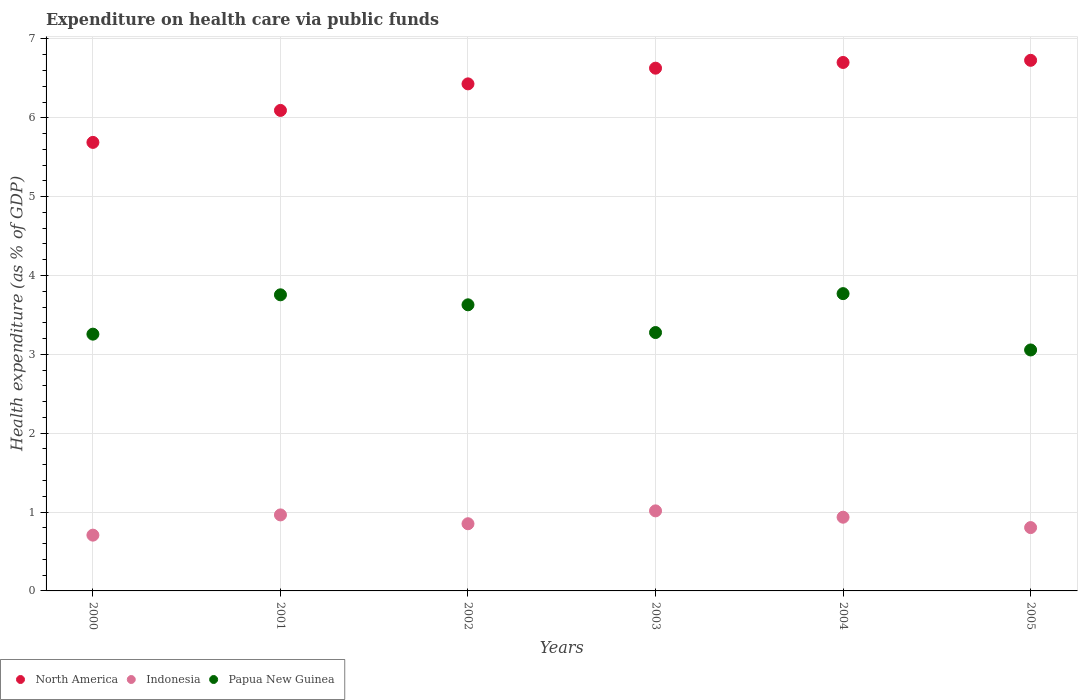How many different coloured dotlines are there?
Your response must be concise. 3. What is the expenditure made on health care in North America in 2005?
Give a very brief answer. 6.73. Across all years, what is the maximum expenditure made on health care in Indonesia?
Make the answer very short. 1.02. Across all years, what is the minimum expenditure made on health care in Indonesia?
Your answer should be very brief. 0.71. In which year was the expenditure made on health care in Indonesia maximum?
Offer a terse response. 2003. In which year was the expenditure made on health care in Indonesia minimum?
Ensure brevity in your answer.  2000. What is the total expenditure made on health care in Papua New Guinea in the graph?
Provide a short and direct response. 20.74. What is the difference between the expenditure made on health care in Indonesia in 2004 and that in 2005?
Provide a succinct answer. 0.13. What is the difference between the expenditure made on health care in North America in 2003 and the expenditure made on health care in Papua New Guinea in 2005?
Your response must be concise. 3.57. What is the average expenditure made on health care in North America per year?
Your response must be concise. 6.38. In the year 2003, what is the difference between the expenditure made on health care in Papua New Guinea and expenditure made on health care in Indonesia?
Provide a succinct answer. 2.26. In how many years, is the expenditure made on health care in Indonesia greater than 2.2 %?
Ensure brevity in your answer.  0. What is the ratio of the expenditure made on health care in North America in 2002 to that in 2004?
Offer a terse response. 0.96. Is the expenditure made on health care in North America in 2003 less than that in 2004?
Offer a terse response. Yes. Is the difference between the expenditure made on health care in Papua New Guinea in 2002 and 2004 greater than the difference between the expenditure made on health care in Indonesia in 2002 and 2004?
Provide a succinct answer. No. What is the difference between the highest and the second highest expenditure made on health care in Indonesia?
Give a very brief answer. 0.05. What is the difference between the highest and the lowest expenditure made on health care in North America?
Offer a terse response. 1.04. In how many years, is the expenditure made on health care in Indonesia greater than the average expenditure made on health care in Indonesia taken over all years?
Your response must be concise. 3. Is the expenditure made on health care in Papua New Guinea strictly less than the expenditure made on health care in Indonesia over the years?
Your answer should be compact. No. What is the difference between two consecutive major ticks on the Y-axis?
Keep it short and to the point. 1. Are the values on the major ticks of Y-axis written in scientific E-notation?
Provide a succinct answer. No. Where does the legend appear in the graph?
Ensure brevity in your answer.  Bottom left. How many legend labels are there?
Give a very brief answer. 3. What is the title of the graph?
Your answer should be compact. Expenditure on health care via public funds. What is the label or title of the X-axis?
Offer a terse response. Years. What is the label or title of the Y-axis?
Your answer should be very brief. Health expenditure (as % of GDP). What is the Health expenditure (as % of GDP) in North America in 2000?
Make the answer very short. 5.69. What is the Health expenditure (as % of GDP) of Indonesia in 2000?
Provide a short and direct response. 0.71. What is the Health expenditure (as % of GDP) of Papua New Guinea in 2000?
Give a very brief answer. 3.26. What is the Health expenditure (as % of GDP) of North America in 2001?
Ensure brevity in your answer.  6.09. What is the Health expenditure (as % of GDP) of Indonesia in 2001?
Make the answer very short. 0.96. What is the Health expenditure (as % of GDP) in Papua New Guinea in 2001?
Give a very brief answer. 3.76. What is the Health expenditure (as % of GDP) of North America in 2002?
Your response must be concise. 6.43. What is the Health expenditure (as % of GDP) of Indonesia in 2002?
Your answer should be very brief. 0.85. What is the Health expenditure (as % of GDP) of Papua New Guinea in 2002?
Keep it short and to the point. 3.63. What is the Health expenditure (as % of GDP) in North America in 2003?
Keep it short and to the point. 6.63. What is the Health expenditure (as % of GDP) of Indonesia in 2003?
Your response must be concise. 1.02. What is the Health expenditure (as % of GDP) in Papua New Guinea in 2003?
Ensure brevity in your answer.  3.28. What is the Health expenditure (as % of GDP) in North America in 2004?
Provide a succinct answer. 6.7. What is the Health expenditure (as % of GDP) in Indonesia in 2004?
Provide a succinct answer. 0.93. What is the Health expenditure (as % of GDP) in Papua New Guinea in 2004?
Offer a terse response. 3.77. What is the Health expenditure (as % of GDP) in North America in 2005?
Provide a short and direct response. 6.73. What is the Health expenditure (as % of GDP) of Indonesia in 2005?
Your answer should be very brief. 0.8. What is the Health expenditure (as % of GDP) of Papua New Guinea in 2005?
Offer a terse response. 3.06. Across all years, what is the maximum Health expenditure (as % of GDP) of North America?
Your answer should be compact. 6.73. Across all years, what is the maximum Health expenditure (as % of GDP) in Indonesia?
Make the answer very short. 1.02. Across all years, what is the maximum Health expenditure (as % of GDP) of Papua New Guinea?
Your answer should be compact. 3.77. Across all years, what is the minimum Health expenditure (as % of GDP) of North America?
Keep it short and to the point. 5.69. Across all years, what is the minimum Health expenditure (as % of GDP) of Indonesia?
Your answer should be very brief. 0.71. Across all years, what is the minimum Health expenditure (as % of GDP) of Papua New Guinea?
Keep it short and to the point. 3.06. What is the total Health expenditure (as % of GDP) in North America in the graph?
Ensure brevity in your answer.  38.27. What is the total Health expenditure (as % of GDP) of Indonesia in the graph?
Ensure brevity in your answer.  5.28. What is the total Health expenditure (as % of GDP) in Papua New Guinea in the graph?
Keep it short and to the point. 20.74. What is the difference between the Health expenditure (as % of GDP) in North America in 2000 and that in 2001?
Provide a succinct answer. -0.41. What is the difference between the Health expenditure (as % of GDP) in Indonesia in 2000 and that in 2001?
Your answer should be compact. -0.26. What is the difference between the Health expenditure (as % of GDP) of Papua New Guinea in 2000 and that in 2001?
Ensure brevity in your answer.  -0.5. What is the difference between the Health expenditure (as % of GDP) in North America in 2000 and that in 2002?
Offer a terse response. -0.74. What is the difference between the Health expenditure (as % of GDP) of Indonesia in 2000 and that in 2002?
Offer a very short reply. -0.14. What is the difference between the Health expenditure (as % of GDP) of Papua New Guinea in 2000 and that in 2002?
Provide a short and direct response. -0.37. What is the difference between the Health expenditure (as % of GDP) in North America in 2000 and that in 2003?
Keep it short and to the point. -0.94. What is the difference between the Health expenditure (as % of GDP) of Indonesia in 2000 and that in 2003?
Keep it short and to the point. -0.31. What is the difference between the Health expenditure (as % of GDP) of Papua New Guinea in 2000 and that in 2003?
Give a very brief answer. -0.02. What is the difference between the Health expenditure (as % of GDP) in North America in 2000 and that in 2004?
Ensure brevity in your answer.  -1.01. What is the difference between the Health expenditure (as % of GDP) in Indonesia in 2000 and that in 2004?
Give a very brief answer. -0.23. What is the difference between the Health expenditure (as % of GDP) in Papua New Guinea in 2000 and that in 2004?
Your response must be concise. -0.51. What is the difference between the Health expenditure (as % of GDP) in North America in 2000 and that in 2005?
Provide a short and direct response. -1.04. What is the difference between the Health expenditure (as % of GDP) of Indonesia in 2000 and that in 2005?
Offer a very short reply. -0.1. What is the difference between the Health expenditure (as % of GDP) in Papua New Guinea in 2000 and that in 2005?
Provide a short and direct response. 0.2. What is the difference between the Health expenditure (as % of GDP) in North America in 2001 and that in 2002?
Your answer should be compact. -0.34. What is the difference between the Health expenditure (as % of GDP) of Indonesia in 2001 and that in 2002?
Give a very brief answer. 0.11. What is the difference between the Health expenditure (as % of GDP) of Papua New Guinea in 2001 and that in 2002?
Give a very brief answer. 0.13. What is the difference between the Health expenditure (as % of GDP) in North America in 2001 and that in 2003?
Give a very brief answer. -0.54. What is the difference between the Health expenditure (as % of GDP) in Indonesia in 2001 and that in 2003?
Provide a succinct answer. -0.05. What is the difference between the Health expenditure (as % of GDP) in Papua New Guinea in 2001 and that in 2003?
Provide a succinct answer. 0.48. What is the difference between the Health expenditure (as % of GDP) in North America in 2001 and that in 2004?
Provide a short and direct response. -0.61. What is the difference between the Health expenditure (as % of GDP) of Indonesia in 2001 and that in 2004?
Your answer should be very brief. 0.03. What is the difference between the Health expenditure (as % of GDP) in Papua New Guinea in 2001 and that in 2004?
Make the answer very short. -0.01. What is the difference between the Health expenditure (as % of GDP) of North America in 2001 and that in 2005?
Keep it short and to the point. -0.64. What is the difference between the Health expenditure (as % of GDP) of Indonesia in 2001 and that in 2005?
Ensure brevity in your answer.  0.16. What is the difference between the Health expenditure (as % of GDP) of Papua New Guinea in 2001 and that in 2005?
Provide a succinct answer. 0.7. What is the difference between the Health expenditure (as % of GDP) of North America in 2002 and that in 2003?
Give a very brief answer. -0.2. What is the difference between the Health expenditure (as % of GDP) in Indonesia in 2002 and that in 2003?
Offer a terse response. -0.16. What is the difference between the Health expenditure (as % of GDP) of Papua New Guinea in 2002 and that in 2003?
Give a very brief answer. 0.35. What is the difference between the Health expenditure (as % of GDP) of North America in 2002 and that in 2004?
Provide a succinct answer. -0.27. What is the difference between the Health expenditure (as % of GDP) of Indonesia in 2002 and that in 2004?
Make the answer very short. -0.08. What is the difference between the Health expenditure (as % of GDP) in Papua New Guinea in 2002 and that in 2004?
Ensure brevity in your answer.  -0.14. What is the difference between the Health expenditure (as % of GDP) in North America in 2002 and that in 2005?
Your answer should be compact. -0.3. What is the difference between the Health expenditure (as % of GDP) of Indonesia in 2002 and that in 2005?
Make the answer very short. 0.05. What is the difference between the Health expenditure (as % of GDP) in Papua New Guinea in 2002 and that in 2005?
Offer a terse response. 0.57. What is the difference between the Health expenditure (as % of GDP) of North America in 2003 and that in 2004?
Provide a short and direct response. -0.07. What is the difference between the Health expenditure (as % of GDP) in Indonesia in 2003 and that in 2004?
Offer a very short reply. 0.08. What is the difference between the Health expenditure (as % of GDP) of Papua New Guinea in 2003 and that in 2004?
Keep it short and to the point. -0.49. What is the difference between the Health expenditure (as % of GDP) of North America in 2003 and that in 2005?
Offer a very short reply. -0.1. What is the difference between the Health expenditure (as % of GDP) of Indonesia in 2003 and that in 2005?
Make the answer very short. 0.21. What is the difference between the Health expenditure (as % of GDP) in Papua New Guinea in 2003 and that in 2005?
Provide a succinct answer. 0.22. What is the difference between the Health expenditure (as % of GDP) in North America in 2004 and that in 2005?
Offer a very short reply. -0.03. What is the difference between the Health expenditure (as % of GDP) of Indonesia in 2004 and that in 2005?
Make the answer very short. 0.13. What is the difference between the Health expenditure (as % of GDP) of North America in 2000 and the Health expenditure (as % of GDP) of Indonesia in 2001?
Ensure brevity in your answer.  4.72. What is the difference between the Health expenditure (as % of GDP) of North America in 2000 and the Health expenditure (as % of GDP) of Papua New Guinea in 2001?
Your answer should be very brief. 1.93. What is the difference between the Health expenditure (as % of GDP) of Indonesia in 2000 and the Health expenditure (as % of GDP) of Papua New Guinea in 2001?
Your response must be concise. -3.05. What is the difference between the Health expenditure (as % of GDP) of North America in 2000 and the Health expenditure (as % of GDP) of Indonesia in 2002?
Keep it short and to the point. 4.84. What is the difference between the Health expenditure (as % of GDP) of North America in 2000 and the Health expenditure (as % of GDP) of Papua New Guinea in 2002?
Your answer should be very brief. 2.06. What is the difference between the Health expenditure (as % of GDP) of Indonesia in 2000 and the Health expenditure (as % of GDP) of Papua New Guinea in 2002?
Your response must be concise. -2.92. What is the difference between the Health expenditure (as % of GDP) of North America in 2000 and the Health expenditure (as % of GDP) of Indonesia in 2003?
Your answer should be compact. 4.67. What is the difference between the Health expenditure (as % of GDP) in North America in 2000 and the Health expenditure (as % of GDP) in Papua New Guinea in 2003?
Offer a terse response. 2.41. What is the difference between the Health expenditure (as % of GDP) of Indonesia in 2000 and the Health expenditure (as % of GDP) of Papua New Guinea in 2003?
Your answer should be very brief. -2.57. What is the difference between the Health expenditure (as % of GDP) of North America in 2000 and the Health expenditure (as % of GDP) of Indonesia in 2004?
Give a very brief answer. 4.75. What is the difference between the Health expenditure (as % of GDP) in North America in 2000 and the Health expenditure (as % of GDP) in Papua New Guinea in 2004?
Ensure brevity in your answer.  1.92. What is the difference between the Health expenditure (as % of GDP) in Indonesia in 2000 and the Health expenditure (as % of GDP) in Papua New Guinea in 2004?
Your response must be concise. -3.06. What is the difference between the Health expenditure (as % of GDP) in North America in 2000 and the Health expenditure (as % of GDP) in Indonesia in 2005?
Keep it short and to the point. 4.88. What is the difference between the Health expenditure (as % of GDP) in North America in 2000 and the Health expenditure (as % of GDP) in Papua New Guinea in 2005?
Your answer should be compact. 2.63. What is the difference between the Health expenditure (as % of GDP) of Indonesia in 2000 and the Health expenditure (as % of GDP) of Papua New Guinea in 2005?
Make the answer very short. -2.35. What is the difference between the Health expenditure (as % of GDP) in North America in 2001 and the Health expenditure (as % of GDP) in Indonesia in 2002?
Ensure brevity in your answer.  5.24. What is the difference between the Health expenditure (as % of GDP) of North America in 2001 and the Health expenditure (as % of GDP) of Papua New Guinea in 2002?
Ensure brevity in your answer.  2.47. What is the difference between the Health expenditure (as % of GDP) of Indonesia in 2001 and the Health expenditure (as % of GDP) of Papua New Guinea in 2002?
Your response must be concise. -2.66. What is the difference between the Health expenditure (as % of GDP) in North America in 2001 and the Health expenditure (as % of GDP) in Indonesia in 2003?
Provide a succinct answer. 5.08. What is the difference between the Health expenditure (as % of GDP) in North America in 2001 and the Health expenditure (as % of GDP) in Papua New Guinea in 2003?
Your answer should be compact. 2.82. What is the difference between the Health expenditure (as % of GDP) of Indonesia in 2001 and the Health expenditure (as % of GDP) of Papua New Guinea in 2003?
Offer a terse response. -2.31. What is the difference between the Health expenditure (as % of GDP) in North America in 2001 and the Health expenditure (as % of GDP) in Indonesia in 2004?
Offer a very short reply. 5.16. What is the difference between the Health expenditure (as % of GDP) in North America in 2001 and the Health expenditure (as % of GDP) in Papua New Guinea in 2004?
Make the answer very short. 2.32. What is the difference between the Health expenditure (as % of GDP) of Indonesia in 2001 and the Health expenditure (as % of GDP) of Papua New Guinea in 2004?
Make the answer very short. -2.81. What is the difference between the Health expenditure (as % of GDP) in North America in 2001 and the Health expenditure (as % of GDP) in Indonesia in 2005?
Provide a succinct answer. 5.29. What is the difference between the Health expenditure (as % of GDP) in North America in 2001 and the Health expenditure (as % of GDP) in Papua New Guinea in 2005?
Your answer should be compact. 3.04. What is the difference between the Health expenditure (as % of GDP) of Indonesia in 2001 and the Health expenditure (as % of GDP) of Papua New Guinea in 2005?
Your answer should be compact. -2.09. What is the difference between the Health expenditure (as % of GDP) in North America in 2002 and the Health expenditure (as % of GDP) in Indonesia in 2003?
Ensure brevity in your answer.  5.41. What is the difference between the Health expenditure (as % of GDP) of North America in 2002 and the Health expenditure (as % of GDP) of Papua New Guinea in 2003?
Provide a short and direct response. 3.15. What is the difference between the Health expenditure (as % of GDP) in Indonesia in 2002 and the Health expenditure (as % of GDP) in Papua New Guinea in 2003?
Offer a very short reply. -2.42. What is the difference between the Health expenditure (as % of GDP) in North America in 2002 and the Health expenditure (as % of GDP) in Indonesia in 2004?
Keep it short and to the point. 5.5. What is the difference between the Health expenditure (as % of GDP) in North America in 2002 and the Health expenditure (as % of GDP) in Papua New Guinea in 2004?
Provide a short and direct response. 2.66. What is the difference between the Health expenditure (as % of GDP) in Indonesia in 2002 and the Health expenditure (as % of GDP) in Papua New Guinea in 2004?
Provide a succinct answer. -2.92. What is the difference between the Health expenditure (as % of GDP) of North America in 2002 and the Health expenditure (as % of GDP) of Indonesia in 2005?
Ensure brevity in your answer.  5.63. What is the difference between the Health expenditure (as % of GDP) of North America in 2002 and the Health expenditure (as % of GDP) of Papua New Guinea in 2005?
Keep it short and to the point. 3.37. What is the difference between the Health expenditure (as % of GDP) in Indonesia in 2002 and the Health expenditure (as % of GDP) in Papua New Guinea in 2005?
Provide a short and direct response. -2.2. What is the difference between the Health expenditure (as % of GDP) in North America in 2003 and the Health expenditure (as % of GDP) in Indonesia in 2004?
Ensure brevity in your answer.  5.69. What is the difference between the Health expenditure (as % of GDP) in North America in 2003 and the Health expenditure (as % of GDP) in Papua New Guinea in 2004?
Your response must be concise. 2.86. What is the difference between the Health expenditure (as % of GDP) in Indonesia in 2003 and the Health expenditure (as % of GDP) in Papua New Guinea in 2004?
Your answer should be very brief. -2.75. What is the difference between the Health expenditure (as % of GDP) of North America in 2003 and the Health expenditure (as % of GDP) of Indonesia in 2005?
Your answer should be compact. 5.83. What is the difference between the Health expenditure (as % of GDP) in North America in 2003 and the Health expenditure (as % of GDP) in Papua New Guinea in 2005?
Your answer should be compact. 3.57. What is the difference between the Health expenditure (as % of GDP) in Indonesia in 2003 and the Health expenditure (as % of GDP) in Papua New Guinea in 2005?
Your answer should be very brief. -2.04. What is the difference between the Health expenditure (as % of GDP) in North America in 2004 and the Health expenditure (as % of GDP) in Indonesia in 2005?
Offer a terse response. 5.9. What is the difference between the Health expenditure (as % of GDP) in North America in 2004 and the Health expenditure (as % of GDP) in Papua New Guinea in 2005?
Provide a short and direct response. 3.65. What is the difference between the Health expenditure (as % of GDP) in Indonesia in 2004 and the Health expenditure (as % of GDP) in Papua New Guinea in 2005?
Ensure brevity in your answer.  -2.12. What is the average Health expenditure (as % of GDP) in North America per year?
Offer a terse response. 6.38. What is the average Health expenditure (as % of GDP) in Indonesia per year?
Provide a short and direct response. 0.88. What is the average Health expenditure (as % of GDP) in Papua New Guinea per year?
Offer a terse response. 3.46. In the year 2000, what is the difference between the Health expenditure (as % of GDP) of North America and Health expenditure (as % of GDP) of Indonesia?
Make the answer very short. 4.98. In the year 2000, what is the difference between the Health expenditure (as % of GDP) of North America and Health expenditure (as % of GDP) of Papua New Guinea?
Ensure brevity in your answer.  2.43. In the year 2000, what is the difference between the Health expenditure (as % of GDP) in Indonesia and Health expenditure (as % of GDP) in Papua New Guinea?
Your response must be concise. -2.55. In the year 2001, what is the difference between the Health expenditure (as % of GDP) in North America and Health expenditure (as % of GDP) in Indonesia?
Offer a terse response. 5.13. In the year 2001, what is the difference between the Health expenditure (as % of GDP) of North America and Health expenditure (as % of GDP) of Papua New Guinea?
Your response must be concise. 2.34. In the year 2001, what is the difference between the Health expenditure (as % of GDP) in Indonesia and Health expenditure (as % of GDP) in Papua New Guinea?
Give a very brief answer. -2.79. In the year 2002, what is the difference between the Health expenditure (as % of GDP) of North America and Health expenditure (as % of GDP) of Indonesia?
Your response must be concise. 5.58. In the year 2002, what is the difference between the Health expenditure (as % of GDP) of North America and Health expenditure (as % of GDP) of Papua New Guinea?
Offer a very short reply. 2.8. In the year 2002, what is the difference between the Health expenditure (as % of GDP) of Indonesia and Health expenditure (as % of GDP) of Papua New Guinea?
Keep it short and to the point. -2.78. In the year 2003, what is the difference between the Health expenditure (as % of GDP) of North America and Health expenditure (as % of GDP) of Indonesia?
Give a very brief answer. 5.61. In the year 2003, what is the difference between the Health expenditure (as % of GDP) of North America and Health expenditure (as % of GDP) of Papua New Guinea?
Ensure brevity in your answer.  3.35. In the year 2003, what is the difference between the Health expenditure (as % of GDP) of Indonesia and Health expenditure (as % of GDP) of Papua New Guinea?
Your answer should be compact. -2.26. In the year 2004, what is the difference between the Health expenditure (as % of GDP) of North America and Health expenditure (as % of GDP) of Indonesia?
Offer a terse response. 5.77. In the year 2004, what is the difference between the Health expenditure (as % of GDP) in North America and Health expenditure (as % of GDP) in Papua New Guinea?
Your answer should be very brief. 2.93. In the year 2004, what is the difference between the Health expenditure (as % of GDP) of Indonesia and Health expenditure (as % of GDP) of Papua New Guinea?
Offer a terse response. -2.84. In the year 2005, what is the difference between the Health expenditure (as % of GDP) in North America and Health expenditure (as % of GDP) in Indonesia?
Your answer should be very brief. 5.93. In the year 2005, what is the difference between the Health expenditure (as % of GDP) of North America and Health expenditure (as % of GDP) of Papua New Guinea?
Keep it short and to the point. 3.67. In the year 2005, what is the difference between the Health expenditure (as % of GDP) in Indonesia and Health expenditure (as % of GDP) in Papua New Guinea?
Offer a terse response. -2.25. What is the ratio of the Health expenditure (as % of GDP) of North America in 2000 to that in 2001?
Provide a succinct answer. 0.93. What is the ratio of the Health expenditure (as % of GDP) of Indonesia in 2000 to that in 2001?
Your response must be concise. 0.73. What is the ratio of the Health expenditure (as % of GDP) in Papua New Guinea in 2000 to that in 2001?
Make the answer very short. 0.87. What is the ratio of the Health expenditure (as % of GDP) of North America in 2000 to that in 2002?
Ensure brevity in your answer.  0.88. What is the ratio of the Health expenditure (as % of GDP) of Indonesia in 2000 to that in 2002?
Give a very brief answer. 0.83. What is the ratio of the Health expenditure (as % of GDP) of Papua New Guinea in 2000 to that in 2002?
Offer a terse response. 0.9. What is the ratio of the Health expenditure (as % of GDP) in North America in 2000 to that in 2003?
Provide a succinct answer. 0.86. What is the ratio of the Health expenditure (as % of GDP) in Indonesia in 2000 to that in 2003?
Make the answer very short. 0.7. What is the ratio of the Health expenditure (as % of GDP) of North America in 2000 to that in 2004?
Make the answer very short. 0.85. What is the ratio of the Health expenditure (as % of GDP) in Indonesia in 2000 to that in 2004?
Your response must be concise. 0.76. What is the ratio of the Health expenditure (as % of GDP) in Papua New Guinea in 2000 to that in 2004?
Give a very brief answer. 0.86. What is the ratio of the Health expenditure (as % of GDP) in North America in 2000 to that in 2005?
Provide a succinct answer. 0.85. What is the ratio of the Health expenditure (as % of GDP) of Indonesia in 2000 to that in 2005?
Your response must be concise. 0.88. What is the ratio of the Health expenditure (as % of GDP) in Papua New Guinea in 2000 to that in 2005?
Keep it short and to the point. 1.07. What is the ratio of the Health expenditure (as % of GDP) of North America in 2001 to that in 2002?
Provide a succinct answer. 0.95. What is the ratio of the Health expenditure (as % of GDP) of Indonesia in 2001 to that in 2002?
Provide a short and direct response. 1.13. What is the ratio of the Health expenditure (as % of GDP) in Papua New Guinea in 2001 to that in 2002?
Your answer should be compact. 1.03. What is the ratio of the Health expenditure (as % of GDP) in North America in 2001 to that in 2003?
Provide a short and direct response. 0.92. What is the ratio of the Health expenditure (as % of GDP) of Indonesia in 2001 to that in 2003?
Your response must be concise. 0.95. What is the ratio of the Health expenditure (as % of GDP) of Papua New Guinea in 2001 to that in 2003?
Your answer should be compact. 1.15. What is the ratio of the Health expenditure (as % of GDP) in North America in 2001 to that in 2004?
Your answer should be very brief. 0.91. What is the ratio of the Health expenditure (as % of GDP) of Indonesia in 2001 to that in 2004?
Your answer should be very brief. 1.03. What is the ratio of the Health expenditure (as % of GDP) of Papua New Guinea in 2001 to that in 2004?
Give a very brief answer. 1. What is the ratio of the Health expenditure (as % of GDP) of North America in 2001 to that in 2005?
Ensure brevity in your answer.  0.91. What is the ratio of the Health expenditure (as % of GDP) of Indonesia in 2001 to that in 2005?
Keep it short and to the point. 1.2. What is the ratio of the Health expenditure (as % of GDP) in Papua New Guinea in 2001 to that in 2005?
Offer a very short reply. 1.23. What is the ratio of the Health expenditure (as % of GDP) of Indonesia in 2002 to that in 2003?
Ensure brevity in your answer.  0.84. What is the ratio of the Health expenditure (as % of GDP) in Papua New Guinea in 2002 to that in 2003?
Provide a succinct answer. 1.11. What is the ratio of the Health expenditure (as % of GDP) of North America in 2002 to that in 2004?
Make the answer very short. 0.96. What is the ratio of the Health expenditure (as % of GDP) of Indonesia in 2002 to that in 2004?
Offer a very short reply. 0.91. What is the ratio of the Health expenditure (as % of GDP) of Papua New Guinea in 2002 to that in 2004?
Provide a short and direct response. 0.96. What is the ratio of the Health expenditure (as % of GDP) in North America in 2002 to that in 2005?
Offer a very short reply. 0.96. What is the ratio of the Health expenditure (as % of GDP) in Indonesia in 2002 to that in 2005?
Your answer should be very brief. 1.06. What is the ratio of the Health expenditure (as % of GDP) in Papua New Guinea in 2002 to that in 2005?
Keep it short and to the point. 1.19. What is the ratio of the Health expenditure (as % of GDP) in North America in 2003 to that in 2004?
Provide a succinct answer. 0.99. What is the ratio of the Health expenditure (as % of GDP) in Indonesia in 2003 to that in 2004?
Your answer should be compact. 1.09. What is the ratio of the Health expenditure (as % of GDP) of Papua New Guinea in 2003 to that in 2004?
Make the answer very short. 0.87. What is the ratio of the Health expenditure (as % of GDP) in North America in 2003 to that in 2005?
Give a very brief answer. 0.99. What is the ratio of the Health expenditure (as % of GDP) of Indonesia in 2003 to that in 2005?
Your answer should be compact. 1.26. What is the ratio of the Health expenditure (as % of GDP) in Papua New Guinea in 2003 to that in 2005?
Make the answer very short. 1.07. What is the ratio of the Health expenditure (as % of GDP) of Indonesia in 2004 to that in 2005?
Offer a very short reply. 1.16. What is the ratio of the Health expenditure (as % of GDP) in Papua New Guinea in 2004 to that in 2005?
Ensure brevity in your answer.  1.23. What is the difference between the highest and the second highest Health expenditure (as % of GDP) in North America?
Make the answer very short. 0.03. What is the difference between the highest and the second highest Health expenditure (as % of GDP) of Indonesia?
Make the answer very short. 0.05. What is the difference between the highest and the second highest Health expenditure (as % of GDP) in Papua New Guinea?
Keep it short and to the point. 0.01. What is the difference between the highest and the lowest Health expenditure (as % of GDP) in North America?
Provide a short and direct response. 1.04. What is the difference between the highest and the lowest Health expenditure (as % of GDP) of Indonesia?
Give a very brief answer. 0.31. 